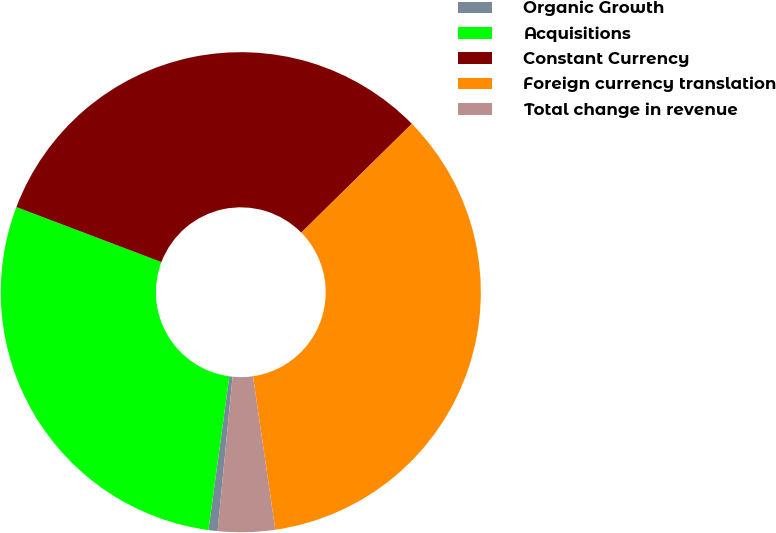<chart> <loc_0><loc_0><loc_500><loc_500><pie_chart><fcel>Organic Growth<fcel>Acquisitions<fcel>Constant Currency<fcel>Foreign currency translation<fcel>Total change in revenue<nl><fcel>0.61%<fcel>28.62%<fcel>31.85%<fcel>35.08%<fcel>3.84%<nl></chart> 